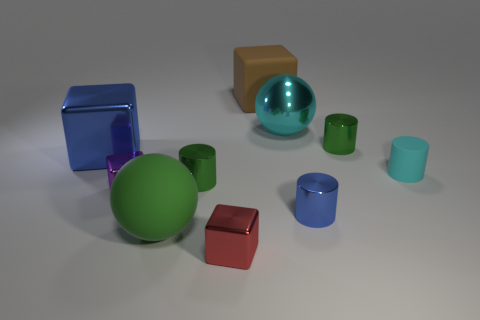Subtract all cylinders. How many objects are left? 6 Add 2 green matte spheres. How many green matte spheres are left? 3 Add 3 cyan cylinders. How many cyan cylinders exist? 4 Subtract 0 red cylinders. How many objects are left? 10 Subtract all gray cylinders. Subtract all big brown rubber things. How many objects are left? 9 